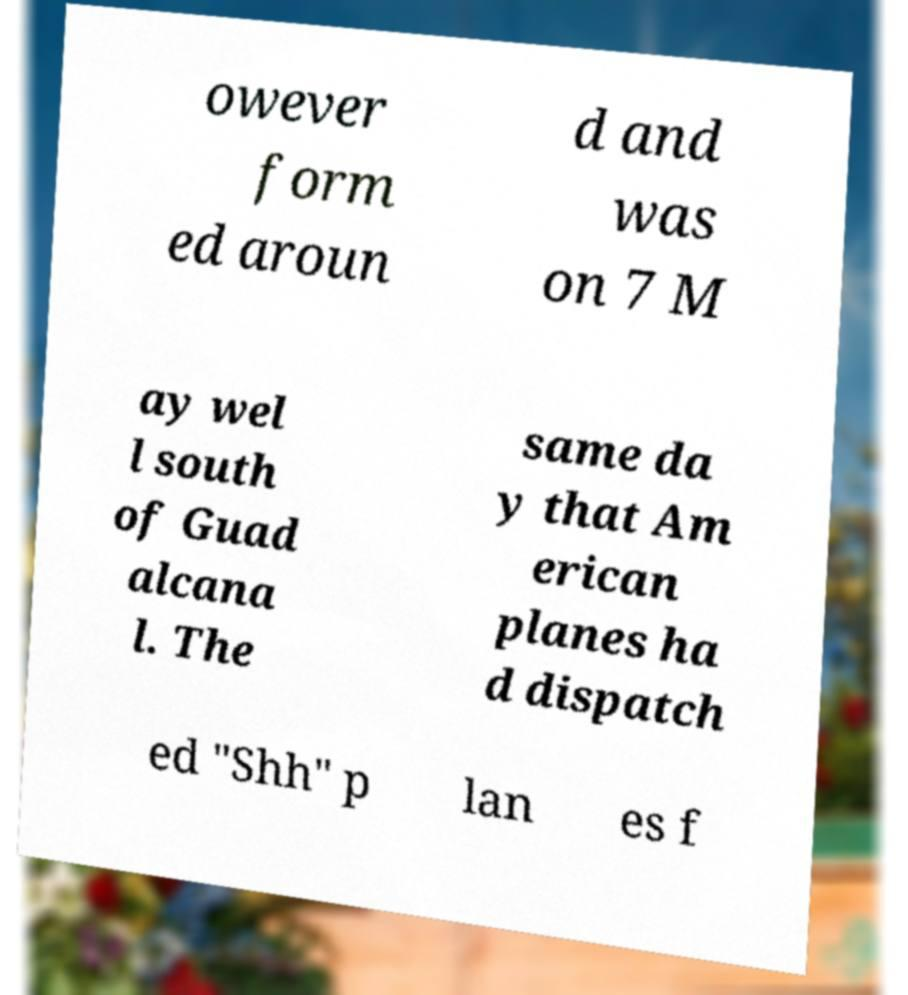There's text embedded in this image that I need extracted. Can you transcribe it verbatim? owever form ed aroun d and was on 7 M ay wel l south of Guad alcana l. The same da y that Am erican planes ha d dispatch ed "Shh" p lan es f 